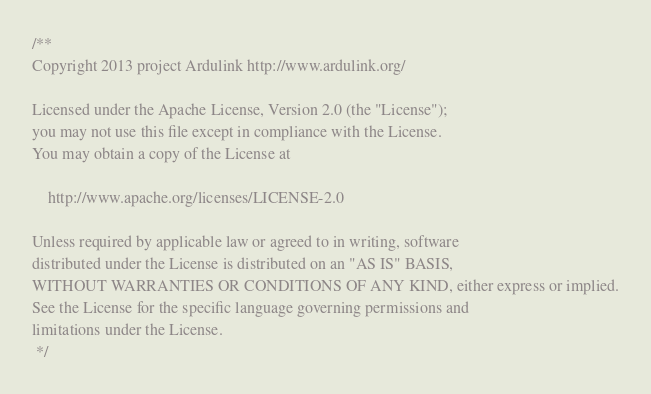<code> <loc_0><loc_0><loc_500><loc_500><_Java_>/**
Copyright 2013 project Ardulink http://www.ardulink.org/
 
Licensed under the Apache License, Version 2.0 (the "License");
you may not use this file except in compliance with the License.
You may obtain a copy of the License at
 
    http://www.apache.org/licenses/LICENSE-2.0
 
Unless required by applicable law or agreed to in writing, software
distributed under the License is distributed on an "AS IS" BASIS,
WITHOUT WARRANTIES OR CONDITIONS OF ANY KIND, either express or implied.
See the License for the specific language governing permissions and
limitations under the License.
 */
</code> 